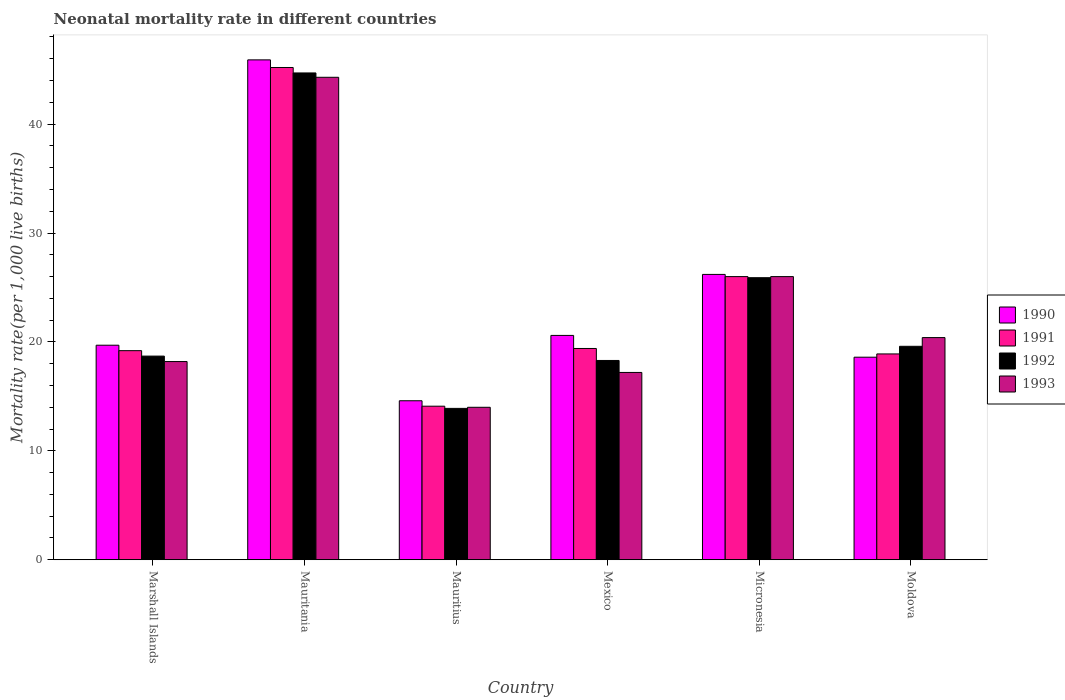How many different coloured bars are there?
Give a very brief answer. 4. How many bars are there on the 1st tick from the left?
Offer a terse response. 4. How many bars are there on the 4th tick from the right?
Make the answer very short. 4. What is the label of the 2nd group of bars from the left?
Your answer should be compact. Mauritania. In how many cases, is the number of bars for a given country not equal to the number of legend labels?
Give a very brief answer. 0. Across all countries, what is the maximum neonatal mortality rate in 1990?
Your answer should be very brief. 45.9. In which country was the neonatal mortality rate in 1991 maximum?
Provide a short and direct response. Mauritania. In which country was the neonatal mortality rate in 1992 minimum?
Provide a short and direct response. Mauritius. What is the total neonatal mortality rate in 1990 in the graph?
Make the answer very short. 145.6. What is the difference between the neonatal mortality rate in 1993 in Mauritania and that in Moldova?
Give a very brief answer. 23.9. What is the difference between the neonatal mortality rate in 1990 in Marshall Islands and the neonatal mortality rate in 1992 in Micronesia?
Give a very brief answer. -6.2. What is the average neonatal mortality rate in 1992 per country?
Offer a very short reply. 23.52. In how many countries, is the neonatal mortality rate in 1992 greater than 28?
Provide a succinct answer. 1. What is the ratio of the neonatal mortality rate in 1990 in Mauritius to that in Moldova?
Your answer should be compact. 0.78. Is the difference between the neonatal mortality rate in 1990 in Mauritius and Moldova greater than the difference between the neonatal mortality rate in 1991 in Mauritius and Moldova?
Your answer should be compact. Yes. What is the difference between the highest and the second highest neonatal mortality rate in 1993?
Your answer should be very brief. -18.3. What is the difference between the highest and the lowest neonatal mortality rate in 1993?
Ensure brevity in your answer.  30.3. In how many countries, is the neonatal mortality rate in 1993 greater than the average neonatal mortality rate in 1993 taken over all countries?
Provide a succinct answer. 2. What does the 3rd bar from the left in Mauritius represents?
Provide a short and direct response. 1992. What does the 4th bar from the right in Micronesia represents?
Offer a very short reply. 1990. Is it the case that in every country, the sum of the neonatal mortality rate in 1992 and neonatal mortality rate in 1991 is greater than the neonatal mortality rate in 1990?
Provide a short and direct response. Yes. How many bars are there?
Provide a succinct answer. 24. What is the difference between two consecutive major ticks on the Y-axis?
Your answer should be very brief. 10. Does the graph contain grids?
Provide a short and direct response. No. How are the legend labels stacked?
Provide a short and direct response. Vertical. What is the title of the graph?
Make the answer very short. Neonatal mortality rate in different countries. What is the label or title of the X-axis?
Make the answer very short. Country. What is the label or title of the Y-axis?
Offer a very short reply. Mortality rate(per 1,0 live births). What is the Mortality rate(per 1,000 live births) of 1990 in Mauritania?
Offer a terse response. 45.9. What is the Mortality rate(per 1,000 live births) of 1991 in Mauritania?
Offer a terse response. 45.2. What is the Mortality rate(per 1,000 live births) of 1992 in Mauritania?
Provide a short and direct response. 44.7. What is the Mortality rate(per 1,000 live births) of 1993 in Mauritania?
Give a very brief answer. 44.3. What is the Mortality rate(per 1,000 live births) of 1991 in Mauritius?
Keep it short and to the point. 14.1. What is the Mortality rate(per 1,000 live births) in 1992 in Mauritius?
Offer a terse response. 13.9. What is the Mortality rate(per 1,000 live births) in 1993 in Mauritius?
Offer a terse response. 14. What is the Mortality rate(per 1,000 live births) of 1990 in Mexico?
Your answer should be very brief. 20.6. What is the Mortality rate(per 1,000 live births) in 1990 in Micronesia?
Keep it short and to the point. 26.2. What is the Mortality rate(per 1,000 live births) in 1992 in Micronesia?
Offer a terse response. 25.9. What is the Mortality rate(per 1,000 live births) of 1990 in Moldova?
Your answer should be very brief. 18.6. What is the Mortality rate(per 1,000 live births) of 1992 in Moldova?
Offer a very short reply. 19.6. What is the Mortality rate(per 1,000 live births) in 1993 in Moldova?
Keep it short and to the point. 20.4. Across all countries, what is the maximum Mortality rate(per 1,000 live births) in 1990?
Offer a very short reply. 45.9. Across all countries, what is the maximum Mortality rate(per 1,000 live births) of 1991?
Your response must be concise. 45.2. Across all countries, what is the maximum Mortality rate(per 1,000 live births) in 1992?
Offer a very short reply. 44.7. Across all countries, what is the maximum Mortality rate(per 1,000 live births) in 1993?
Your answer should be very brief. 44.3. What is the total Mortality rate(per 1,000 live births) of 1990 in the graph?
Offer a terse response. 145.6. What is the total Mortality rate(per 1,000 live births) of 1991 in the graph?
Keep it short and to the point. 142.8. What is the total Mortality rate(per 1,000 live births) of 1992 in the graph?
Offer a very short reply. 141.1. What is the total Mortality rate(per 1,000 live births) of 1993 in the graph?
Your answer should be compact. 140.1. What is the difference between the Mortality rate(per 1,000 live births) of 1990 in Marshall Islands and that in Mauritania?
Make the answer very short. -26.2. What is the difference between the Mortality rate(per 1,000 live births) of 1991 in Marshall Islands and that in Mauritania?
Provide a short and direct response. -26. What is the difference between the Mortality rate(per 1,000 live births) in 1992 in Marshall Islands and that in Mauritania?
Offer a terse response. -26. What is the difference between the Mortality rate(per 1,000 live births) in 1993 in Marshall Islands and that in Mauritania?
Offer a terse response. -26.1. What is the difference between the Mortality rate(per 1,000 live births) of 1991 in Marshall Islands and that in Mauritius?
Give a very brief answer. 5.1. What is the difference between the Mortality rate(per 1,000 live births) in 1992 in Marshall Islands and that in Mauritius?
Offer a very short reply. 4.8. What is the difference between the Mortality rate(per 1,000 live births) of 1990 in Marshall Islands and that in Mexico?
Make the answer very short. -0.9. What is the difference between the Mortality rate(per 1,000 live births) in 1991 in Marshall Islands and that in Mexico?
Ensure brevity in your answer.  -0.2. What is the difference between the Mortality rate(per 1,000 live births) in 1992 in Marshall Islands and that in Mexico?
Your response must be concise. 0.4. What is the difference between the Mortality rate(per 1,000 live births) in 1993 in Marshall Islands and that in Mexico?
Make the answer very short. 1. What is the difference between the Mortality rate(per 1,000 live births) of 1993 in Marshall Islands and that in Micronesia?
Provide a short and direct response. -7.8. What is the difference between the Mortality rate(per 1,000 live births) of 1990 in Marshall Islands and that in Moldova?
Ensure brevity in your answer.  1.1. What is the difference between the Mortality rate(per 1,000 live births) of 1990 in Mauritania and that in Mauritius?
Make the answer very short. 31.3. What is the difference between the Mortality rate(per 1,000 live births) in 1991 in Mauritania and that in Mauritius?
Ensure brevity in your answer.  31.1. What is the difference between the Mortality rate(per 1,000 live births) of 1992 in Mauritania and that in Mauritius?
Provide a short and direct response. 30.8. What is the difference between the Mortality rate(per 1,000 live births) of 1993 in Mauritania and that in Mauritius?
Your answer should be compact. 30.3. What is the difference between the Mortality rate(per 1,000 live births) in 1990 in Mauritania and that in Mexico?
Provide a short and direct response. 25.3. What is the difference between the Mortality rate(per 1,000 live births) of 1991 in Mauritania and that in Mexico?
Keep it short and to the point. 25.8. What is the difference between the Mortality rate(per 1,000 live births) in 1992 in Mauritania and that in Mexico?
Give a very brief answer. 26.4. What is the difference between the Mortality rate(per 1,000 live births) of 1993 in Mauritania and that in Mexico?
Keep it short and to the point. 27.1. What is the difference between the Mortality rate(per 1,000 live births) in 1991 in Mauritania and that in Micronesia?
Your answer should be compact. 19.2. What is the difference between the Mortality rate(per 1,000 live births) in 1992 in Mauritania and that in Micronesia?
Your response must be concise. 18.8. What is the difference between the Mortality rate(per 1,000 live births) of 1990 in Mauritania and that in Moldova?
Offer a terse response. 27.3. What is the difference between the Mortality rate(per 1,000 live births) of 1991 in Mauritania and that in Moldova?
Offer a terse response. 26.3. What is the difference between the Mortality rate(per 1,000 live births) of 1992 in Mauritania and that in Moldova?
Your answer should be compact. 25.1. What is the difference between the Mortality rate(per 1,000 live births) in 1993 in Mauritania and that in Moldova?
Ensure brevity in your answer.  23.9. What is the difference between the Mortality rate(per 1,000 live births) in 1990 in Mauritius and that in Mexico?
Your response must be concise. -6. What is the difference between the Mortality rate(per 1,000 live births) in 1991 in Mauritius and that in Mexico?
Give a very brief answer. -5.3. What is the difference between the Mortality rate(per 1,000 live births) of 1992 in Mauritius and that in Mexico?
Offer a terse response. -4.4. What is the difference between the Mortality rate(per 1,000 live births) of 1990 in Mauritius and that in Micronesia?
Ensure brevity in your answer.  -11.6. What is the difference between the Mortality rate(per 1,000 live births) in 1992 in Mauritius and that in Micronesia?
Your answer should be compact. -12. What is the difference between the Mortality rate(per 1,000 live births) of 1992 in Mauritius and that in Moldova?
Keep it short and to the point. -5.7. What is the difference between the Mortality rate(per 1,000 live births) of 1990 in Mexico and that in Micronesia?
Offer a very short reply. -5.6. What is the difference between the Mortality rate(per 1,000 live births) of 1993 in Mexico and that in Micronesia?
Ensure brevity in your answer.  -8.8. What is the difference between the Mortality rate(per 1,000 live births) in 1991 in Mexico and that in Moldova?
Give a very brief answer. 0.5. What is the difference between the Mortality rate(per 1,000 live births) of 1992 in Mexico and that in Moldova?
Your answer should be compact. -1.3. What is the difference between the Mortality rate(per 1,000 live births) of 1992 in Micronesia and that in Moldova?
Your answer should be very brief. 6.3. What is the difference between the Mortality rate(per 1,000 live births) of 1993 in Micronesia and that in Moldova?
Provide a succinct answer. 5.6. What is the difference between the Mortality rate(per 1,000 live births) of 1990 in Marshall Islands and the Mortality rate(per 1,000 live births) of 1991 in Mauritania?
Give a very brief answer. -25.5. What is the difference between the Mortality rate(per 1,000 live births) in 1990 in Marshall Islands and the Mortality rate(per 1,000 live births) in 1993 in Mauritania?
Ensure brevity in your answer.  -24.6. What is the difference between the Mortality rate(per 1,000 live births) of 1991 in Marshall Islands and the Mortality rate(per 1,000 live births) of 1992 in Mauritania?
Make the answer very short. -25.5. What is the difference between the Mortality rate(per 1,000 live births) in 1991 in Marshall Islands and the Mortality rate(per 1,000 live births) in 1993 in Mauritania?
Your answer should be compact. -25.1. What is the difference between the Mortality rate(per 1,000 live births) of 1992 in Marshall Islands and the Mortality rate(per 1,000 live births) of 1993 in Mauritania?
Offer a very short reply. -25.6. What is the difference between the Mortality rate(per 1,000 live births) of 1990 in Marshall Islands and the Mortality rate(per 1,000 live births) of 1993 in Mauritius?
Your answer should be very brief. 5.7. What is the difference between the Mortality rate(per 1,000 live births) of 1992 in Marshall Islands and the Mortality rate(per 1,000 live births) of 1993 in Mauritius?
Make the answer very short. 4.7. What is the difference between the Mortality rate(per 1,000 live births) of 1990 in Marshall Islands and the Mortality rate(per 1,000 live births) of 1991 in Mexico?
Offer a very short reply. 0.3. What is the difference between the Mortality rate(per 1,000 live births) of 1990 in Marshall Islands and the Mortality rate(per 1,000 live births) of 1991 in Micronesia?
Your response must be concise. -6.3. What is the difference between the Mortality rate(per 1,000 live births) in 1991 in Marshall Islands and the Mortality rate(per 1,000 live births) in 1992 in Micronesia?
Keep it short and to the point. -6.7. What is the difference between the Mortality rate(per 1,000 live births) in 1991 in Marshall Islands and the Mortality rate(per 1,000 live births) in 1993 in Micronesia?
Ensure brevity in your answer.  -6.8. What is the difference between the Mortality rate(per 1,000 live births) in 1991 in Marshall Islands and the Mortality rate(per 1,000 live births) in 1993 in Moldova?
Offer a terse response. -1.2. What is the difference between the Mortality rate(per 1,000 live births) of 1990 in Mauritania and the Mortality rate(per 1,000 live births) of 1991 in Mauritius?
Make the answer very short. 31.8. What is the difference between the Mortality rate(per 1,000 live births) in 1990 in Mauritania and the Mortality rate(per 1,000 live births) in 1993 in Mauritius?
Offer a terse response. 31.9. What is the difference between the Mortality rate(per 1,000 live births) in 1991 in Mauritania and the Mortality rate(per 1,000 live births) in 1992 in Mauritius?
Offer a very short reply. 31.3. What is the difference between the Mortality rate(per 1,000 live births) in 1991 in Mauritania and the Mortality rate(per 1,000 live births) in 1993 in Mauritius?
Your response must be concise. 31.2. What is the difference between the Mortality rate(per 1,000 live births) of 1992 in Mauritania and the Mortality rate(per 1,000 live births) of 1993 in Mauritius?
Make the answer very short. 30.7. What is the difference between the Mortality rate(per 1,000 live births) in 1990 in Mauritania and the Mortality rate(per 1,000 live births) in 1991 in Mexico?
Your answer should be compact. 26.5. What is the difference between the Mortality rate(per 1,000 live births) in 1990 in Mauritania and the Mortality rate(per 1,000 live births) in 1992 in Mexico?
Your response must be concise. 27.6. What is the difference between the Mortality rate(per 1,000 live births) in 1990 in Mauritania and the Mortality rate(per 1,000 live births) in 1993 in Mexico?
Keep it short and to the point. 28.7. What is the difference between the Mortality rate(per 1,000 live births) of 1991 in Mauritania and the Mortality rate(per 1,000 live births) of 1992 in Mexico?
Provide a succinct answer. 26.9. What is the difference between the Mortality rate(per 1,000 live births) of 1992 in Mauritania and the Mortality rate(per 1,000 live births) of 1993 in Mexico?
Provide a succinct answer. 27.5. What is the difference between the Mortality rate(per 1,000 live births) in 1990 in Mauritania and the Mortality rate(per 1,000 live births) in 1991 in Micronesia?
Make the answer very short. 19.9. What is the difference between the Mortality rate(per 1,000 live births) of 1990 in Mauritania and the Mortality rate(per 1,000 live births) of 1993 in Micronesia?
Make the answer very short. 19.9. What is the difference between the Mortality rate(per 1,000 live births) of 1991 in Mauritania and the Mortality rate(per 1,000 live births) of 1992 in Micronesia?
Provide a short and direct response. 19.3. What is the difference between the Mortality rate(per 1,000 live births) in 1991 in Mauritania and the Mortality rate(per 1,000 live births) in 1993 in Micronesia?
Offer a terse response. 19.2. What is the difference between the Mortality rate(per 1,000 live births) of 1990 in Mauritania and the Mortality rate(per 1,000 live births) of 1992 in Moldova?
Offer a very short reply. 26.3. What is the difference between the Mortality rate(per 1,000 live births) in 1990 in Mauritania and the Mortality rate(per 1,000 live births) in 1993 in Moldova?
Make the answer very short. 25.5. What is the difference between the Mortality rate(per 1,000 live births) of 1991 in Mauritania and the Mortality rate(per 1,000 live births) of 1992 in Moldova?
Provide a succinct answer. 25.6. What is the difference between the Mortality rate(per 1,000 live births) in 1991 in Mauritania and the Mortality rate(per 1,000 live births) in 1993 in Moldova?
Provide a succinct answer. 24.8. What is the difference between the Mortality rate(per 1,000 live births) in 1992 in Mauritania and the Mortality rate(per 1,000 live births) in 1993 in Moldova?
Your answer should be very brief. 24.3. What is the difference between the Mortality rate(per 1,000 live births) of 1991 in Mauritius and the Mortality rate(per 1,000 live births) of 1993 in Mexico?
Offer a very short reply. -3.1. What is the difference between the Mortality rate(per 1,000 live births) in 1992 in Mauritius and the Mortality rate(per 1,000 live births) in 1993 in Mexico?
Give a very brief answer. -3.3. What is the difference between the Mortality rate(per 1,000 live births) of 1990 in Mauritius and the Mortality rate(per 1,000 live births) of 1993 in Micronesia?
Provide a short and direct response. -11.4. What is the difference between the Mortality rate(per 1,000 live births) in 1991 in Mauritius and the Mortality rate(per 1,000 live births) in 1993 in Micronesia?
Ensure brevity in your answer.  -11.9. What is the difference between the Mortality rate(per 1,000 live births) in 1990 in Mauritius and the Mortality rate(per 1,000 live births) in 1991 in Moldova?
Keep it short and to the point. -4.3. What is the difference between the Mortality rate(per 1,000 live births) in 1990 in Mauritius and the Mortality rate(per 1,000 live births) in 1992 in Moldova?
Provide a succinct answer. -5. What is the difference between the Mortality rate(per 1,000 live births) of 1990 in Mauritius and the Mortality rate(per 1,000 live births) of 1993 in Moldova?
Make the answer very short. -5.8. What is the difference between the Mortality rate(per 1,000 live births) in 1991 in Mauritius and the Mortality rate(per 1,000 live births) in 1993 in Moldova?
Your answer should be very brief. -6.3. What is the difference between the Mortality rate(per 1,000 live births) of 1990 in Mexico and the Mortality rate(per 1,000 live births) of 1991 in Micronesia?
Offer a very short reply. -5.4. What is the difference between the Mortality rate(per 1,000 live births) in 1990 in Mexico and the Mortality rate(per 1,000 live births) in 1993 in Micronesia?
Your answer should be compact. -5.4. What is the difference between the Mortality rate(per 1,000 live births) in 1991 in Mexico and the Mortality rate(per 1,000 live births) in 1992 in Micronesia?
Ensure brevity in your answer.  -6.5. What is the difference between the Mortality rate(per 1,000 live births) in 1991 in Mexico and the Mortality rate(per 1,000 live births) in 1993 in Micronesia?
Your answer should be very brief. -6.6. What is the difference between the Mortality rate(per 1,000 live births) in 1990 in Mexico and the Mortality rate(per 1,000 live births) in 1991 in Moldova?
Provide a short and direct response. 1.7. What is the difference between the Mortality rate(per 1,000 live births) in 1990 in Mexico and the Mortality rate(per 1,000 live births) in 1992 in Moldova?
Provide a succinct answer. 1. What is the difference between the Mortality rate(per 1,000 live births) of 1990 in Mexico and the Mortality rate(per 1,000 live births) of 1993 in Moldova?
Give a very brief answer. 0.2. What is the difference between the Mortality rate(per 1,000 live births) of 1991 in Mexico and the Mortality rate(per 1,000 live births) of 1992 in Moldova?
Make the answer very short. -0.2. What is the difference between the Mortality rate(per 1,000 live births) in 1991 in Mexico and the Mortality rate(per 1,000 live births) in 1993 in Moldova?
Provide a succinct answer. -1. What is the difference between the Mortality rate(per 1,000 live births) in 1992 in Mexico and the Mortality rate(per 1,000 live births) in 1993 in Moldova?
Provide a succinct answer. -2.1. What is the difference between the Mortality rate(per 1,000 live births) in 1990 in Micronesia and the Mortality rate(per 1,000 live births) in 1992 in Moldova?
Provide a short and direct response. 6.6. What is the difference between the Mortality rate(per 1,000 live births) of 1991 in Micronesia and the Mortality rate(per 1,000 live births) of 1993 in Moldova?
Make the answer very short. 5.6. What is the average Mortality rate(per 1,000 live births) of 1990 per country?
Offer a very short reply. 24.27. What is the average Mortality rate(per 1,000 live births) of 1991 per country?
Offer a very short reply. 23.8. What is the average Mortality rate(per 1,000 live births) in 1992 per country?
Keep it short and to the point. 23.52. What is the average Mortality rate(per 1,000 live births) of 1993 per country?
Ensure brevity in your answer.  23.35. What is the difference between the Mortality rate(per 1,000 live births) in 1990 and Mortality rate(per 1,000 live births) in 1991 in Marshall Islands?
Your response must be concise. 0.5. What is the difference between the Mortality rate(per 1,000 live births) in 1990 and Mortality rate(per 1,000 live births) in 1993 in Marshall Islands?
Make the answer very short. 1.5. What is the difference between the Mortality rate(per 1,000 live births) in 1991 and Mortality rate(per 1,000 live births) in 1992 in Marshall Islands?
Keep it short and to the point. 0.5. What is the difference between the Mortality rate(per 1,000 live births) of 1990 and Mortality rate(per 1,000 live births) of 1992 in Mauritania?
Give a very brief answer. 1.2. What is the difference between the Mortality rate(per 1,000 live births) of 1991 and Mortality rate(per 1,000 live births) of 1993 in Mauritania?
Keep it short and to the point. 0.9. What is the difference between the Mortality rate(per 1,000 live births) of 1991 and Mortality rate(per 1,000 live births) of 1992 in Mauritius?
Your answer should be very brief. 0.2. What is the difference between the Mortality rate(per 1,000 live births) in 1990 and Mortality rate(per 1,000 live births) in 1991 in Mexico?
Offer a terse response. 1.2. What is the difference between the Mortality rate(per 1,000 live births) of 1990 and Mortality rate(per 1,000 live births) of 1993 in Mexico?
Your answer should be compact. 3.4. What is the difference between the Mortality rate(per 1,000 live births) of 1990 and Mortality rate(per 1,000 live births) of 1992 in Micronesia?
Offer a terse response. 0.3. What is the difference between the Mortality rate(per 1,000 live births) in 1992 and Mortality rate(per 1,000 live births) in 1993 in Micronesia?
Keep it short and to the point. -0.1. What is the difference between the Mortality rate(per 1,000 live births) in 1990 and Mortality rate(per 1,000 live births) in 1991 in Moldova?
Offer a very short reply. -0.3. What is the difference between the Mortality rate(per 1,000 live births) of 1990 and Mortality rate(per 1,000 live births) of 1993 in Moldova?
Your answer should be compact. -1.8. What is the difference between the Mortality rate(per 1,000 live births) of 1991 and Mortality rate(per 1,000 live births) of 1993 in Moldova?
Your answer should be very brief. -1.5. What is the difference between the Mortality rate(per 1,000 live births) in 1992 and Mortality rate(per 1,000 live births) in 1993 in Moldova?
Offer a very short reply. -0.8. What is the ratio of the Mortality rate(per 1,000 live births) of 1990 in Marshall Islands to that in Mauritania?
Your answer should be compact. 0.43. What is the ratio of the Mortality rate(per 1,000 live births) of 1991 in Marshall Islands to that in Mauritania?
Provide a succinct answer. 0.42. What is the ratio of the Mortality rate(per 1,000 live births) of 1992 in Marshall Islands to that in Mauritania?
Provide a succinct answer. 0.42. What is the ratio of the Mortality rate(per 1,000 live births) of 1993 in Marshall Islands to that in Mauritania?
Give a very brief answer. 0.41. What is the ratio of the Mortality rate(per 1,000 live births) in 1990 in Marshall Islands to that in Mauritius?
Give a very brief answer. 1.35. What is the ratio of the Mortality rate(per 1,000 live births) of 1991 in Marshall Islands to that in Mauritius?
Give a very brief answer. 1.36. What is the ratio of the Mortality rate(per 1,000 live births) of 1992 in Marshall Islands to that in Mauritius?
Provide a short and direct response. 1.35. What is the ratio of the Mortality rate(per 1,000 live births) of 1990 in Marshall Islands to that in Mexico?
Your answer should be compact. 0.96. What is the ratio of the Mortality rate(per 1,000 live births) in 1992 in Marshall Islands to that in Mexico?
Offer a very short reply. 1.02. What is the ratio of the Mortality rate(per 1,000 live births) in 1993 in Marshall Islands to that in Mexico?
Make the answer very short. 1.06. What is the ratio of the Mortality rate(per 1,000 live births) of 1990 in Marshall Islands to that in Micronesia?
Give a very brief answer. 0.75. What is the ratio of the Mortality rate(per 1,000 live births) in 1991 in Marshall Islands to that in Micronesia?
Ensure brevity in your answer.  0.74. What is the ratio of the Mortality rate(per 1,000 live births) in 1992 in Marshall Islands to that in Micronesia?
Your response must be concise. 0.72. What is the ratio of the Mortality rate(per 1,000 live births) in 1990 in Marshall Islands to that in Moldova?
Make the answer very short. 1.06. What is the ratio of the Mortality rate(per 1,000 live births) in 1991 in Marshall Islands to that in Moldova?
Provide a short and direct response. 1.02. What is the ratio of the Mortality rate(per 1,000 live births) in 1992 in Marshall Islands to that in Moldova?
Keep it short and to the point. 0.95. What is the ratio of the Mortality rate(per 1,000 live births) in 1993 in Marshall Islands to that in Moldova?
Give a very brief answer. 0.89. What is the ratio of the Mortality rate(per 1,000 live births) of 1990 in Mauritania to that in Mauritius?
Provide a short and direct response. 3.14. What is the ratio of the Mortality rate(per 1,000 live births) in 1991 in Mauritania to that in Mauritius?
Your response must be concise. 3.21. What is the ratio of the Mortality rate(per 1,000 live births) of 1992 in Mauritania to that in Mauritius?
Make the answer very short. 3.22. What is the ratio of the Mortality rate(per 1,000 live births) of 1993 in Mauritania to that in Mauritius?
Offer a terse response. 3.16. What is the ratio of the Mortality rate(per 1,000 live births) in 1990 in Mauritania to that in Mexico?
Ensure brevity in your answer.  2.23. What is the ratio of the Mortality rate(per 1,000 live births) of 1991 in Mauritania to that in Mexico?
Provide a short and direct response. 2.33. What is the ratio of the Mortality rate(per 1,000 live births) of 1992 in Mauritania to that in Mexico?
Keep it short and to the point. 2.44. What is the ratio of the Mortality rate(per 1,000 live births) of 1993 in Mauritania to that in Mexico?
Keep it short and to the point. 2.58. What is the ratio of the Mortality rate(per 1,000 live births) of 1990 in Mauritania to that in Micronesia?
Make the answer very short. 1.75. What is the ratio of the Mortality rate(per 1,000 live births) of 1991 in Mauritania to that in Micronesia?
Provide a short and direct response. 1.74. What is the ratio of the Mortality rate(per 1,000 live births) of 1992 in Mauritania to that in Micronesia?
Provide a succinct answer. 1.73. What is the ratio of the Mortality rate(per 1,000 live births) of 1993 in Mauritania to that in Micronesia?
Ensure brevity in your answer.  1.7. What is the ratio of the Mortality rate(per 1,000 live births) of 1990 in Mauritania to that in Moldova?
Ensure brevity in your answer.  2.47. What is the ratio of the Mortality rate(per 1,000 live births) of 1991 in Mauritania to that in Moldova?
Your answer should be very brief. 2.39. What is the ratio of the Mortality rate(per 1,000 live births) of 1992 in Mauritania to that in Moldova?
Make the answer very short. 2.28. What is the ratio of the Mortality rate(per 1,000 live births) of 1993 in Mauritania to that in Moldova?
Provide a short and direct response. 2.17. What is the ratio of the Mortality rate(per 1,000 live births) in 1990 in Mauritius to that in Mexico?
Your answer should be compact. 0.71. What is the ratio of the Mortality rate(per 1,000 live births) in 1991 in Mauritius to that in Mexico?
Your answer should be very brief. 0.73. What is the ratio of the Mortality rate(per 1,000 live births) in 1992 in Mauritius to that in Mexico?
Give a very brief answer. 0.76. What is the ratio of the Mortality rate(per 1,000 live births) of 1993 in Mauritius to that in Mexico?
Ensure brevity in your answer.  0.81. What is the ratio of the Mortality rate(per 1,000 live births) of 1990 in Mauritius to that in Micronesia?
Offer a very short reply. 0.56. What is the ratio of the Mortality rate(per 1,000 live births) in 1991 in Mauritius to that in Micronesia?
Offer a very short reply. 0.54. What is the ratio of the Mortality rate(per 1,000 live births) in 1992 in Mauritius to that in Micronesia?
Ensure brevity in your answer.  0.54. What is the ratio of the Mortality rate(per 1,000 live births) of 1993 in Mauritius to that in Micronesia?
Offer a very short reply. 0.54. What is the ratio of the Mortality rate(per 1,000 live births) in 1990 in Mauritius to that in Moldova?
Your answer should be very brief. 0.78. What is the ratio of the Mortality rate(per 1,000 live births) of 1991 in Mauritius to that in Moldova?
Provide a succinct answer. 0.75. What is the ratio of the Mortality rate(per 1,000 live births) in 1992 in Mauritius to that in Moldova?
Your response must be concise. 0.71. What is the ratio of the Mortality rate(per 1,000 live births) in 1993 in Mauritius to that in Moldova?
Provide a succinct answer. 0.69. What is the ratio of the Mortality rate(per 1,000 live births) in 1990 in Mexico to that in Micronesia?
Give a very brief answer. 0.79. What is the ratio of the Mortality rate(per 1,000 live births) in 1991 in Mexico to that in Micronesia?
Provide a succinct answer. 0.75. What is the ratio of the Mortality rate(per 1,000 live births) of 1992 in Mexico to that in Micronesia?
Offer a terse response. 0.71. What is the ratio of the Mortality rate(per 1,000 live births) of 1993 in Mexico to that in Micronesia?
Provide a succinct answer. 0.66. What is the ratio of the Mortality rate(per 1,000 live births) in 1990 in Mexico to that in Moldova?
Offer a very short reply. 1.11. What is the ratio of the Mortality rate(per 1,000 live births) of 1991 in Mexico to that in Moldova?
Ensure brevity in your answer.  1.03. What is the ratio of the Mortality rate(per 1,000 live births) in 1992 in Mexico to that in Moldova?
Provide a short and direct response. 0.93. What is the ratio of the Mortality rate(per 1,000 live births) in 1993 in Mexico to that in Moldova?
Provide a succinct answer. 0.84. What is the ratio of the Mortality rate(per 1,000 live births) in 1990 in Micronesia to that in Moldova?
Offer a terse response. 1.41. What is the ratio of the Mortality rate(per 1,000 live births) of 1991 in Micronesia to that in Moldova?
Provide a succinct answer. 1.38. What is the ratio of the Mortality rate(per 1,000 live births) in 1992 in Micronesia to that in Moldova?
Your answer should be very brief. 1.32. What is the ratio of the Mortality rate(per 1,000 live births) in 1993 in Micronesia to that in Moldova?
Offer a very short reply. 1.27. What is the difference between the highest and the second highest Mortality rate(per 1,000 live births) of 1991?
Provide a succinct answer. 19.2. What is the difference between the highest and the second highest Mortality rate(per 1,000 live births) of 1992?
Your answer should be compact. 18.8. What is the difference between the highest and the second highest Mortality rate(per 1,000 live births) of 1993?
Your answer should be compact. 18.3. What is the difference between the highest and the lowest Mortality rate(per 1,000 live births) of 1990?
Your answer should be very brief. 31.3. What is the difference between the highest and the lowest Mortality rate(per 1,000 live births) of 1991?
Give a very brief answer. 31.1. What is the difference between the highest and the lowest Mortality rate(per 1,000 live births) of 1992?
Give a very brief answer. 30.8. What is the difference between the highest and the lowest Mortality rate(per 1,000 live births) in 1993?
Your answer should be very brief. 30.3. 